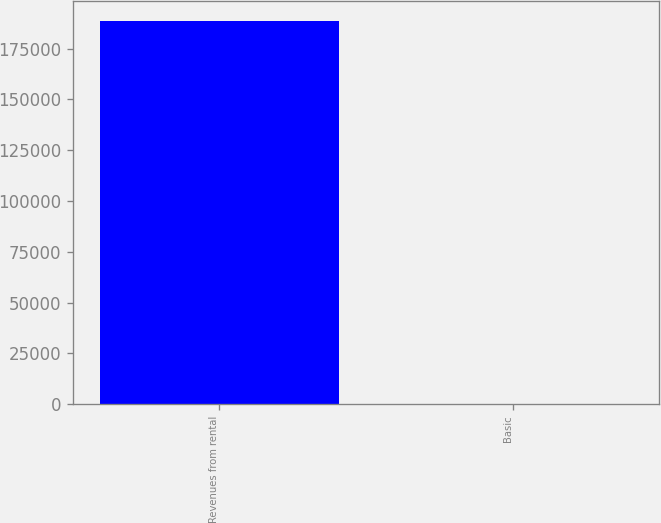Convert chart. <chart><loc_0><loc_0><loc_500><loc_500><bar_chart><fcel>Revenues from rental<fcel>Basic<nl><fcel>188794<fcel>0.34<nl></chart> 